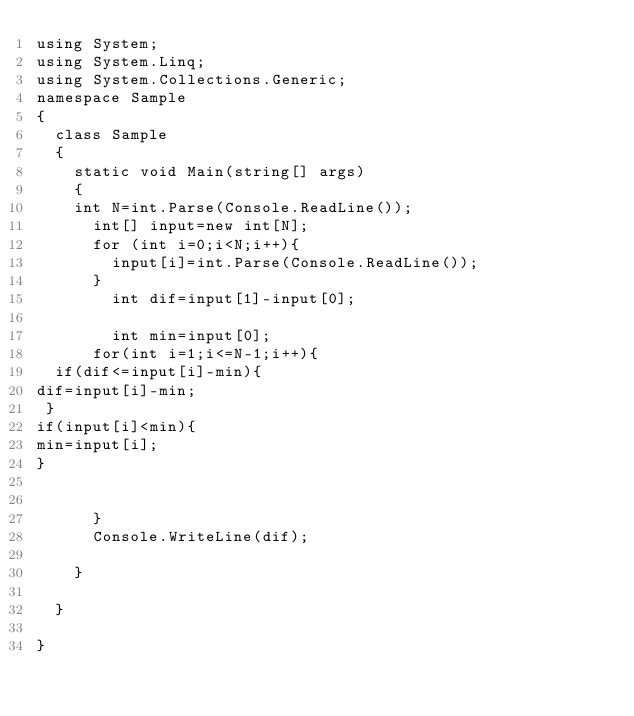<code> <loc_0><loc_0><loc_500><loc_500><_C#_>using System;
using System.Linq;
using System.Collections.Generic;
namespace Sample
{
  class Sample
  {
    static void Main(string[] args)
    {
    int N=int.Parse(Console.ReadLine());
      int[] input=new int[N];
      for (int i=0;i<N;i++){
        input[i]=int.Parse(Console.ReadLine());
      }
        int dif=input[1]-input[0];

        int min=input[0];
      for(int i=1;i<=N-1;i++){
  if(dif<=input[i]-min){
dif=input[i]-min;
 }        
if(input[i]<min){
min=input[i];
}
      
        
      }
      Console.WriteLine(dif);
     
    }
    
  }

}

</code> 